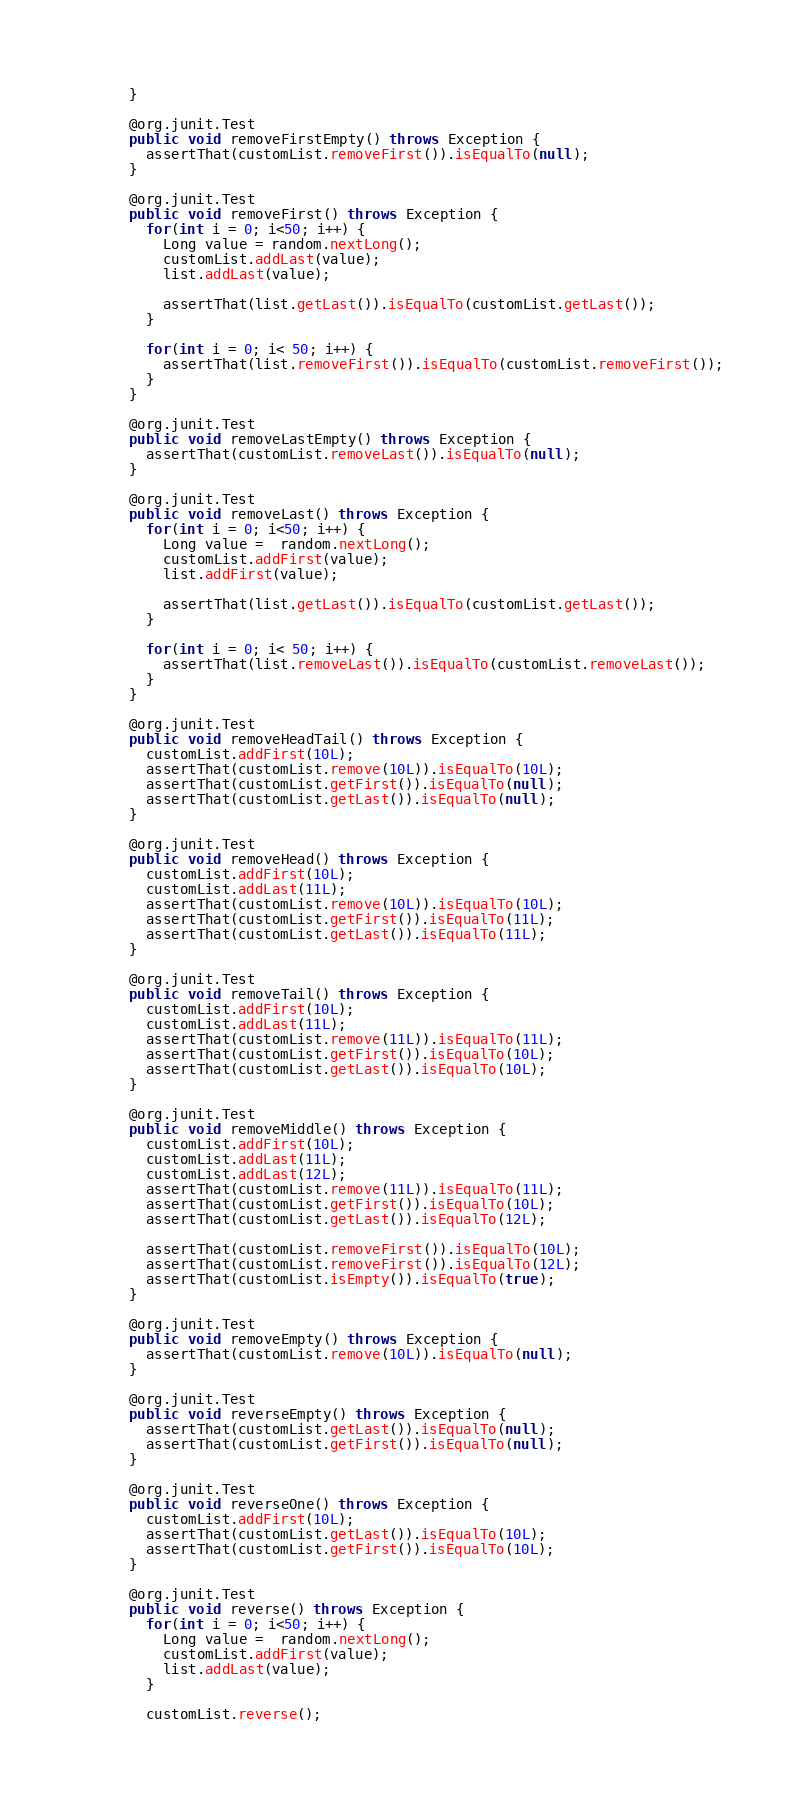Convert code to text. <code><loc_0><loc_0><loc_500><loc_500><_Java_>  }

  @org.junit.Test
  public void removeFirstEmpty() throws Exception {
    assertThat(customList.removeFirst()).isEqualTo(null);
  }

  @org.junit.Test
  public void removeFirst() throws Exception {
    for(int i = 0; i<50; i++) {
      Long value = random.nextLong();
      customList.addLast(value);
      list.addLast(value);

      assertThat(list.getLast()).isEqualTo(customList.getLast());
    }

    for(int i = 0; i< 50; i++) {
      assertThat(list.removeFirst()).isEqualTo(customList.removeFirst());
    }
  }

  @org.junit.Test
  public void removeLastEmpty() throws Exception {
    assertThat(customList.removeLast()).isEqualTo(null);
  }

  @org.junit.Test
  public void removeLast() throws Exception {
    for(int i = 0; i<50; i++) {
      Long value =  random.nextLong();
      customList.addFirst(value);
      list.addFirst(value);

      assertThat(list.getLast()).isEqualTo(customList.getLast());
    }

    for(int i = 0; i< 50; i++) {
      assertThat(list.removeLast()).isEqualTo(customList.removeLast());
    }
  }

  @org.junit.Test
  public void removeHeadTail() throws Exception {
    customList.addFirst(10L);
    assertThat(customList.remove(10L)).isEqualTo(10L);
    assertThat(customList.getFirst()).isEqualTo(null);
    assertThat(customList.getLast()).isEqualTo(null);
  }

  @org.junit.Test
  public void removeHead() throws Exception {
    customList.addFirst(10L);
    customList.addLast(11L);
    assertThat(customList.remove(10L)).isEqualTo(10L);
    assertThat(customList.getFirst()).isEqualTo(11L);
    assertThat(customList.getLast()).isEqualTo(11L);
  }

  @org.junit.Test
  public void removeTail() throws Exception {
    customList.addFirst(10L);
    customList.addLast(11L);
    assertThat(customList.remove(11L)).isEqualTo(11L);
    assertThat(customList.getFirst()).isEqualTo(10L);
    assertThat(customList.getLast()).isEqualTo(10L);
  }

  @org.junit.Test
  public void removeMiddle() throws Exception {
    customList.addFirst(10L);
    customList.addLast(11L);
    customList.addLast(12L);
    assertThat(customList.remove(11L)).isEqualTo(11L);
    assertThat(customList.getFirst()).isEqualTo(10L);
    assertThat(customList.getLast()).isEqualTo(12L);

    assertThat(customList.removeFirst()).isEqualTo(10L);
    assertThat(customList.removeFirst()).isEqualTo(12L);
    assertThat(customList.isEmpty()).isEqualTo(true);
  }

  @org.junit.Test
  public void removeEmpty() throws Exception {
    assertThat(customList.remove(10L)).isEqualTo(null);
  }

  @org.junit.Test
  public void reverseEmpty() throws Exception {
    assertThat(customList.getLast()).isEqualTo(null);
    assertThat(customList.getFirst()).isEqualTo(null);
  }

  @org.junit.Test
  public void reverseOne() throws Exception {
    customList.addFirst(10L);
    assertThat(customList.getLast()).isEqualTo(10L);
    assertThat(customList.getFirst()).isEqualTo(10L);
  }

  @org.junit.Test
  public void reverse() throws Exception {
    for(int i = 0; i<50; i++) {
      Long value =  random.nextLong();
      customList.addFirst(value);
      list.addLast(value);
    }

    customList.reverse();
</code> 